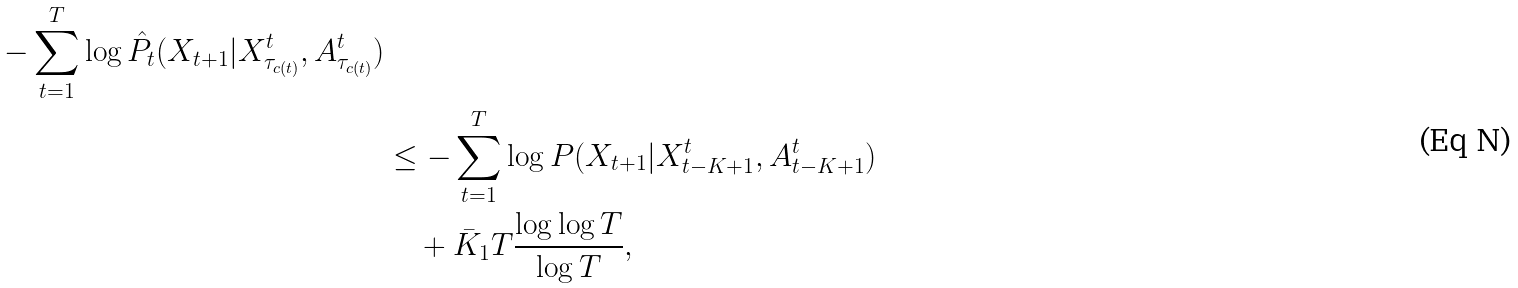Convert formula to latex. <formula><loc_0><loc_0><loc_500><loc_500>{ - \sum _ { t = 1 } ^ { T } \log \hat { P } _ { t } ( X _ { t + 1 } | X ^ { t } _ { \tau _ { c ( t ) } } , A ^ { t } _ { \tau _ { c ( t ) } } ) } \\ & \leq - \sum _ { t = 1 } ^ { T } \log P ( X _ { t + 1 } | X ^ { t } _ { t - K + 1 } , A ^ { t } _ { t - K + 1 } ) \\ & \quad + \bar { K } _ { 1 } T \frac { \log \log T } { \log T } ,</formula> 